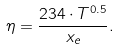<formula> <loc_0><loc_0><loc_500><loc_500>\eta = \frac { 2 3 4 \cdot T ^ { 0 . 5 } } { x _ { e } } .</formula> 